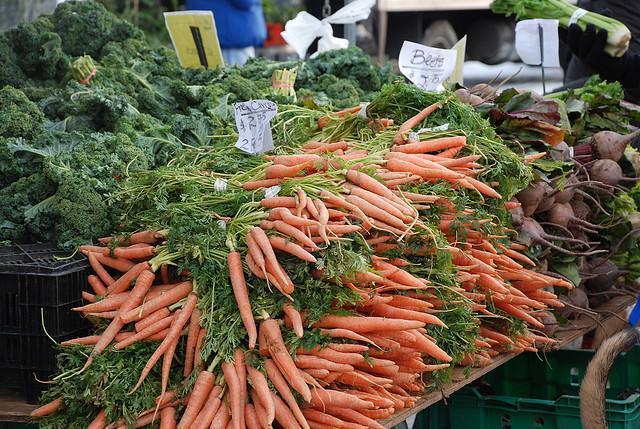How many different colors do you see on the carrots?
Give a very brief answer. 2. How many carrots can be seen?
Give a very brief answer. 2. How many broccolis are in the photo?
Give a very brief answer. 6. 